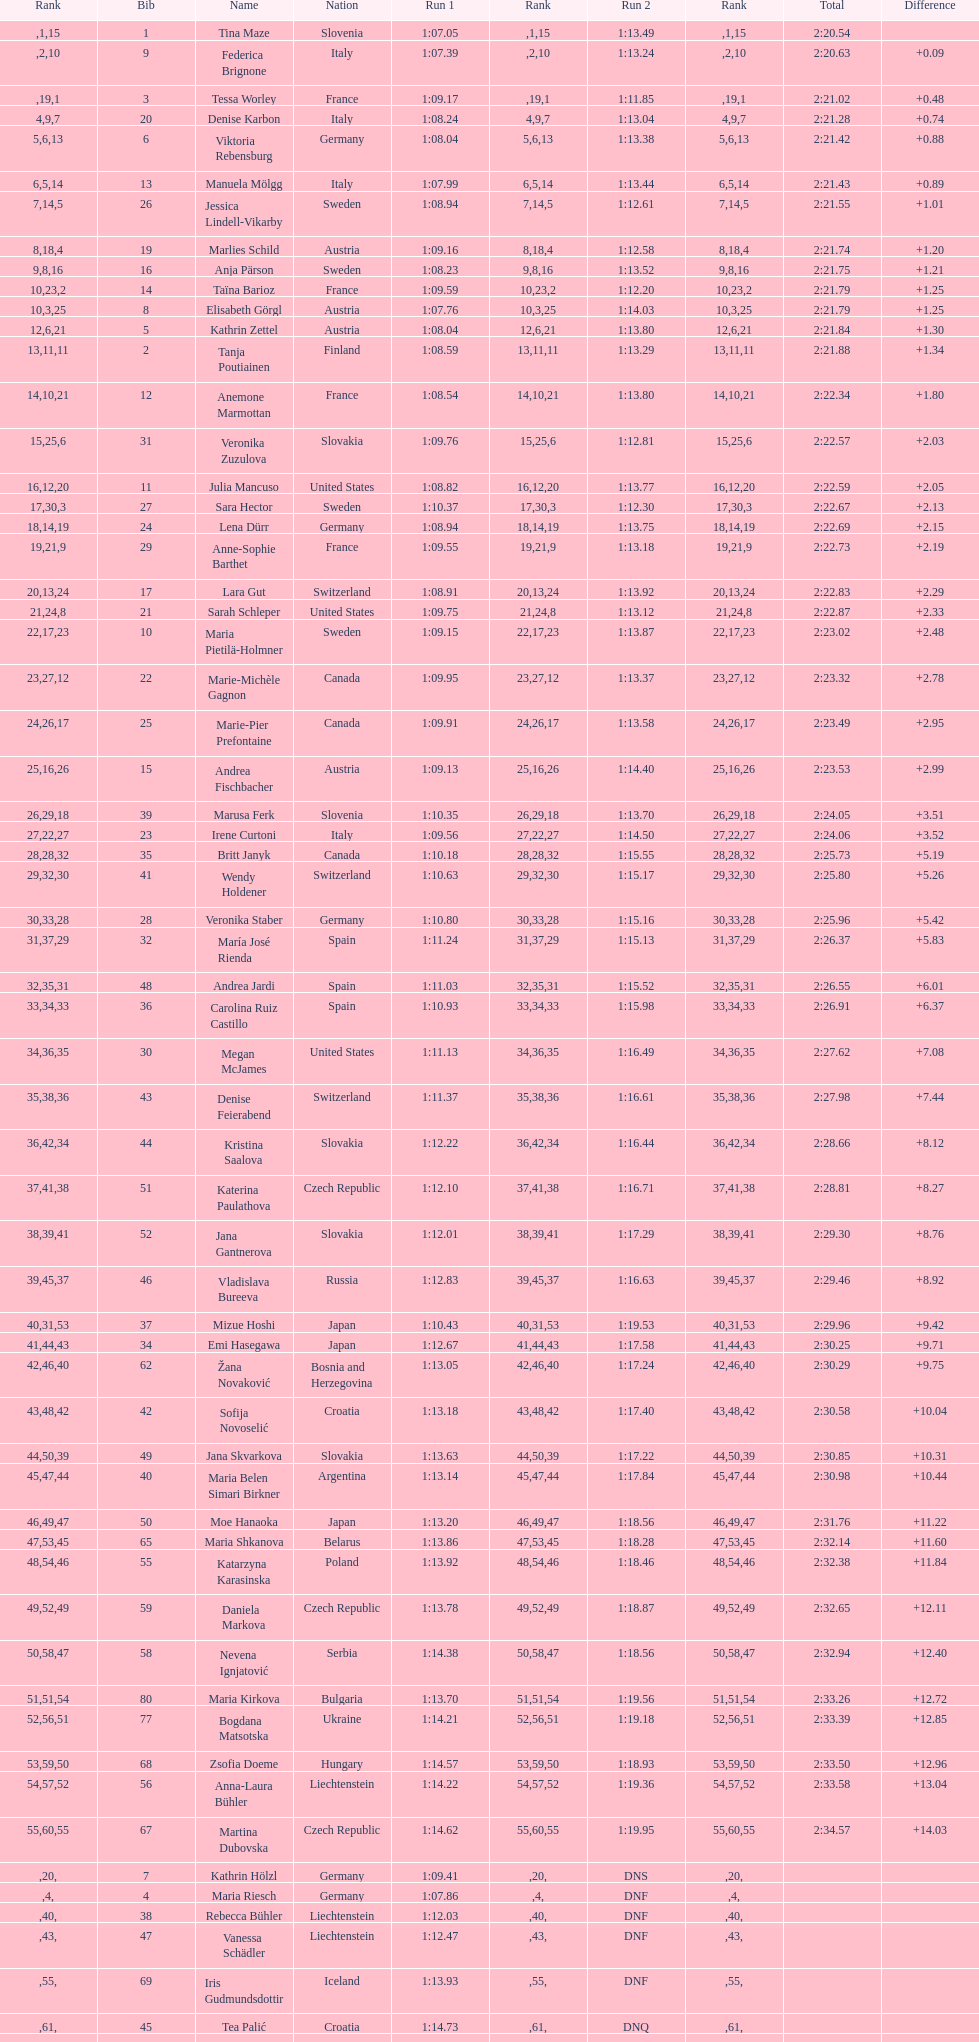What is the name before anja parson? Marlies Schild. 